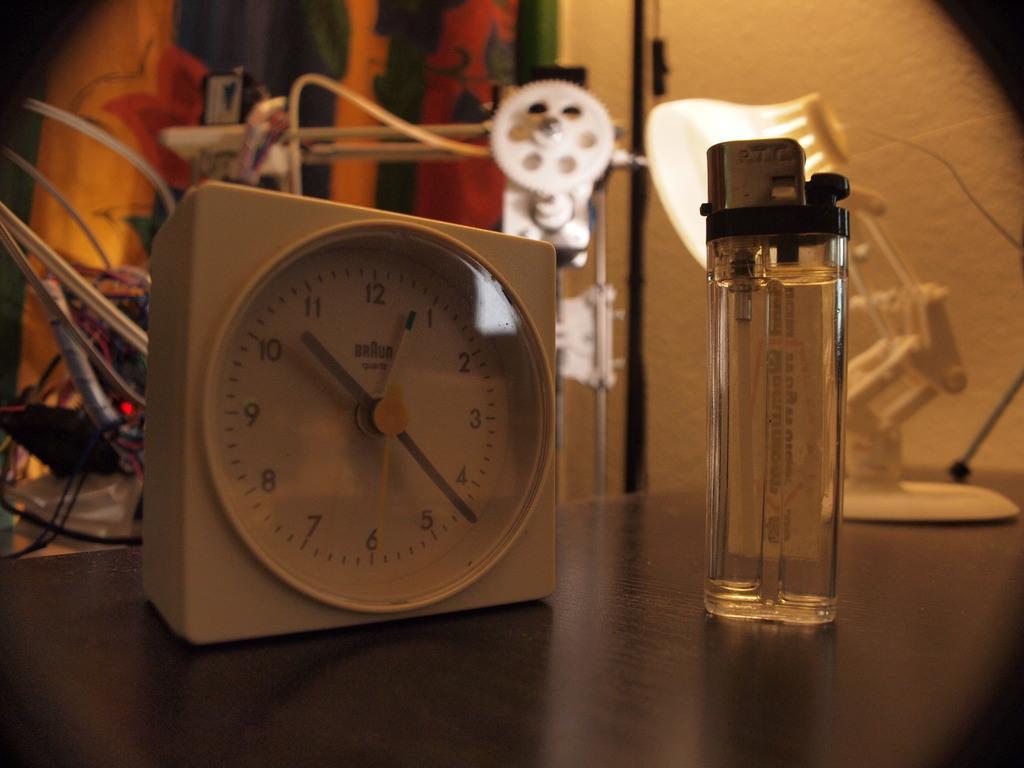How would you summarize this image in a sentence or two? In this image we can see a clock, lighter, light on a stand on a platform. In the background we can see cables, device, objects and the wall. 